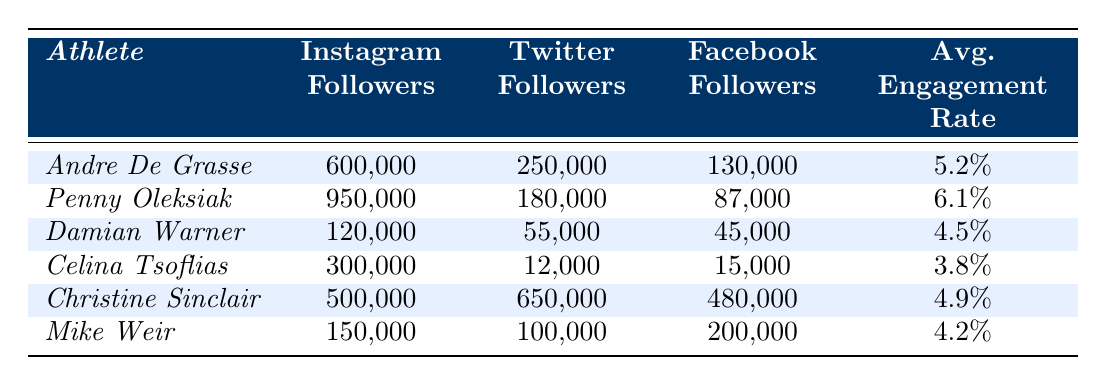What's the total number of Instagram followers for all the athletes listed? To find the total number of Instagram followers, add each athlete's Instagram followers: 600000 (Andre De Grasse) + 950000 (Penny Oleksiak) + 120000 (Damian Warner) + 300000 (Celina Tsoflias) + 500000 (Christine Sinclair) + 150000 (Mike Weir) = 2620000.
Answer: 2620000 Which athlete has the highest number of Twitter followers? According to the table, Christine Sinclair has 650000 Twitter followers, which is more than any other athlete listed.
Answer: Christine Sinclair What is the average engagement rate of Andre De Grasse and Christine Sinclair combined? First, find the individual engagement rates: Andre De Grasse has 5.2% and Christine Sinclair has 4.9%. The average is calculated as: (5.2 + 4.9)/2 = 5.05%.
Answer: 5.05% Is Penny Oleksiak more popular on Instagram than Andre De Grasse? On Instagram, Penny Oleksiak has 950000 followers while Andre De Grasse has 600000 followers, indicating that Penny is indeed more popular.
Answer: Yes Which athlete has fewer than 100,000 followers on both Twitter and Facebook? Damian Warner has 55000 Twitter followers and 45000 Facebook followers, both under 100,000, which is true of no other athlete.
Answer: Damian Warner What is the difference in average engagement rate between Penny Oleksiak and Mike Weir? Penny Oleksiak has an engagement rate of 6.1% and Mike Weir has 4.2%. The difference is 6.1 - 4.2 = 1.9%.
Answer: 1.9% How many more followers does Christine Sinclair have on Facebook than on Instagram? Christine Sinclair has 480000 followers on Facebook and 500000 on Instagram. The difference is 480000 - 500000 = -20000, indicating she has 20000 fewer followers on Facebook compared to Instagram.
Answer: 20000 fewer If we rank the athletes based on their total followers across all platforms, who comes in third? Calculating total followers: Andre De Grasse = 980000, Penny Oleksiak = 1117000, Damian Warner = 215000, Celina Tsoflias = 327000, Christine Sinclair = 1635000, Mike Weir = 450000. Ranking gives: 1) Penny Oleksiak, 2) Christine Sinclair, 3) Andre De Grasse.
Answer: Andre De Grasse What percentage of the total Twitter followers across all athletes do Andre De Grasse's followers represent? First, add up the Twitter followers: 250000 (De Grasse) + 180000 + 55000 + 12000 + 650000 + 100000 = 1105000. The percentage is (250000 / 1105000) * 100 = 22.62%.
Answer: 22.62% Which athlete has the least number of followers on Facebook? The athlete with the least Facebook followers is Celina Tsoflias with 15000 followers.
Answer: Celina Tsoflias 